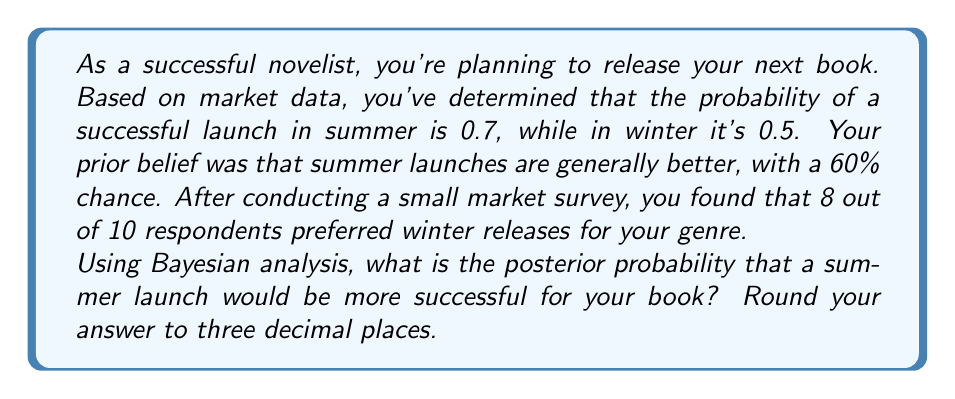Provide a solution to this math problem. Let's approach this step-by-step using Bayes' theorem:

1) Define our events:
   S: Summer launch is more successful
   D: Data from the survey (8 out of 10 prefer winter)

2) We need to calculate P(S|D) using Bayes' theorem:

   $$P(S|D) = \frac{P(D|S) \cdot P(S)}{P(D)}$$

3) We know:
   P(S) = 0.6 (prior probability of summer being better)
   P(D|S) = probability of getting 8 winter preferences if summer is actually better
   
4) To calculate P(D|S), we use the binomial probability:

   $$P(D|S) = \binom{10}{8} (0.3)^8 (0.7)^2 = 0.0087$$

   Because if summer is better, the probability of someone preferring winter is 1 - 0.7 = 0.3

5) We also need P(D|not S), which is the probability of getting 8 winter preferences if winter is actually better:

   $$P(D|not S) = \binom{10}{8} (0.5)^8 (0.5)^2 = 0.0439$$

6) Now we can calculate P(D):

   $$P(D) = P(D|S) \cdot P(S) + P(D|not S) \cdot P(not S)$$
   $$P(D) = 0.0087 \cdot 0.6 + 0.0439 \cdot 0.4 = 0.0228$$

7) Finally, we can calculate P(S|D):

   $$P(S|D) = \frac{0.0087 \cdot 0.6}{0.0228} = 0.2289$$

8) Rounding to three decimal places: 0.229
Answer: 0.229 